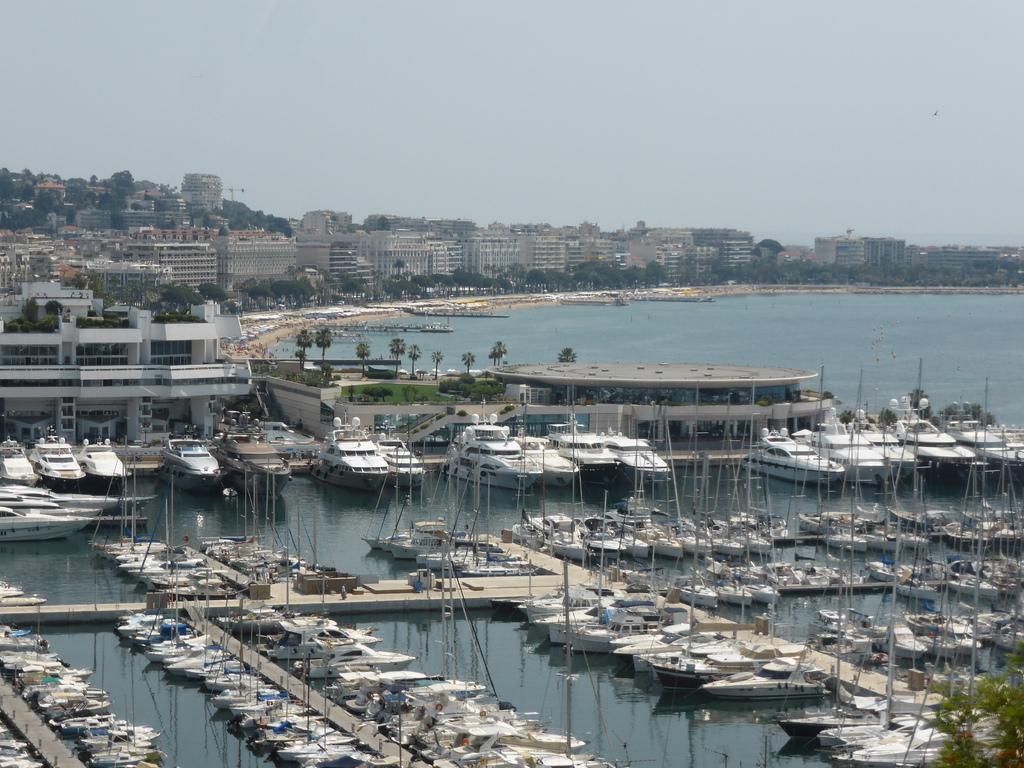How would you summarize this image in a sentence or two? In this image I can see few boats and ships on the water and I can also see the bridge. In the background I can see few trees in green color, buildings and the sky is in white and blue color. 